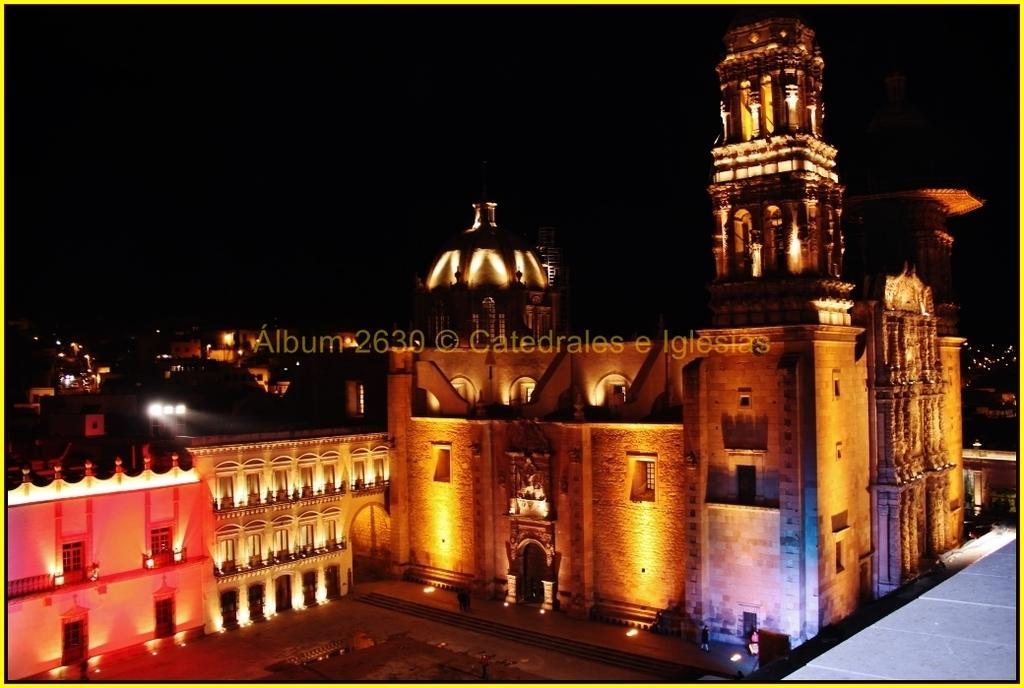Can you describe this image briefly? The image is taken from some website, there is a beautiful fort with many lights and behind the fort there are some other houses. 